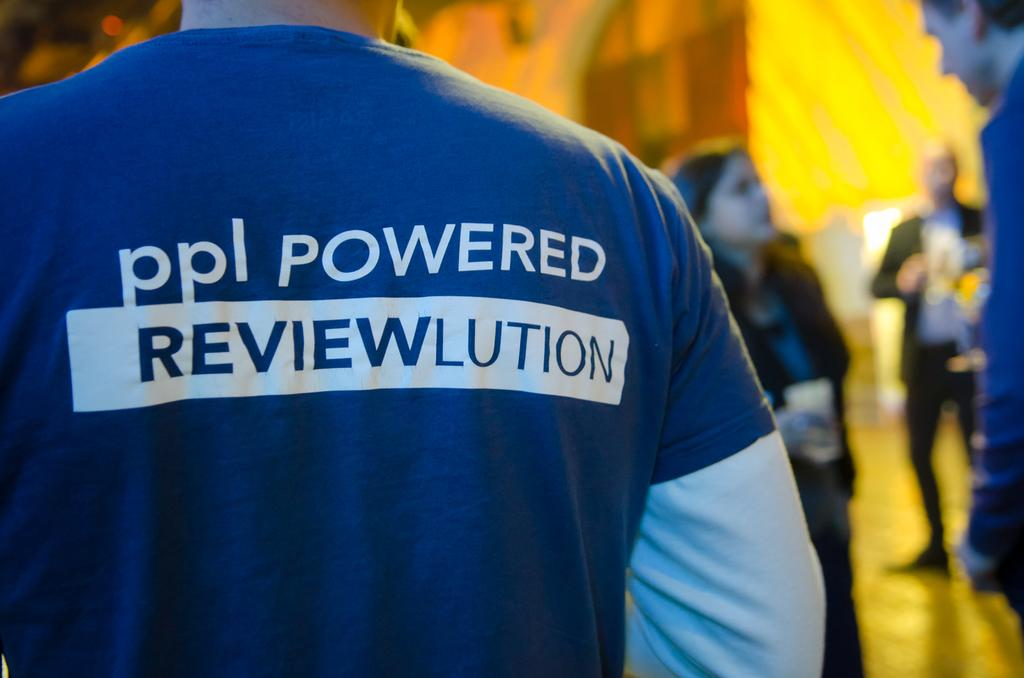<image>
Render a clear and concise summary of the photo. Man standing in a picture with a ppl powered reviewlution shirt on 